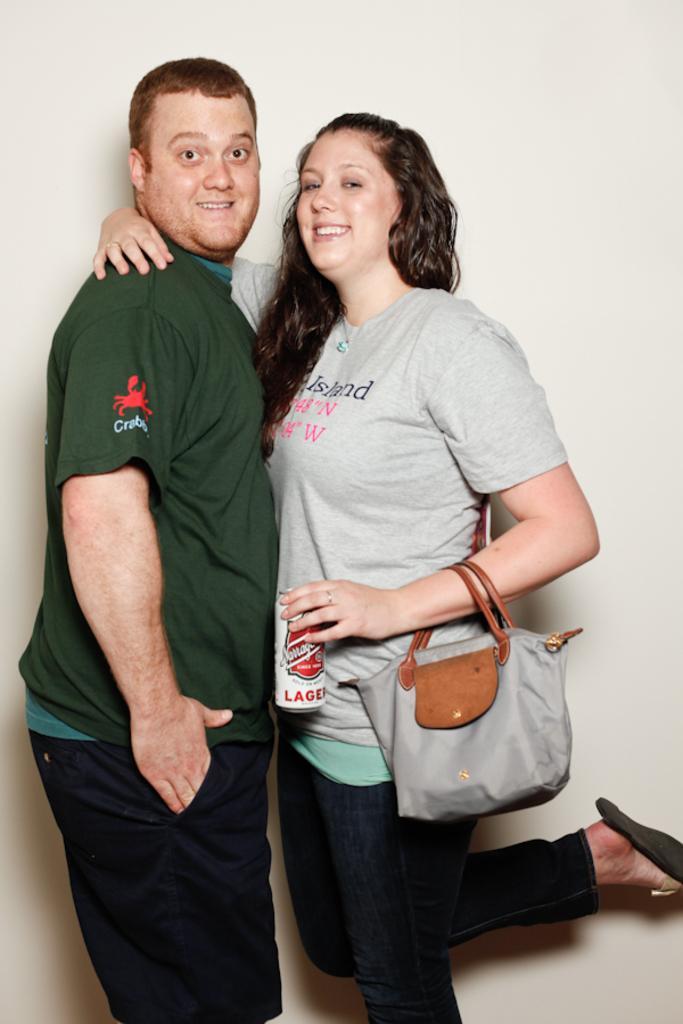Can you describe this image briefly? In this image on the left side there is one man who is standing and he is smiling, and on the right side there is one woman who is standing and she is holding a coke container and also she is wearing a handbag. 